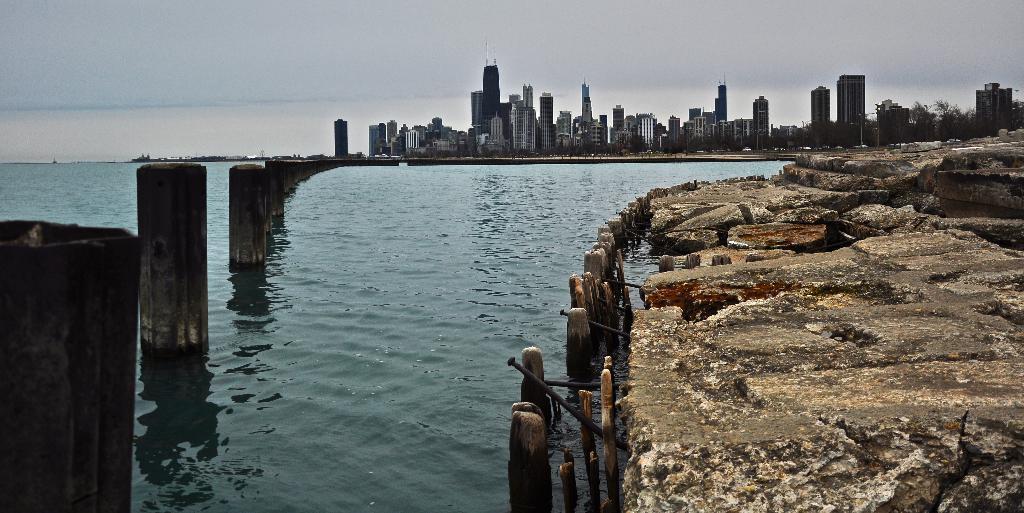In one or two sentences, can you explain what this image depicts? As we can see in the image there is water, poles, buildings, rocks and sky. On the right side there are trees. 